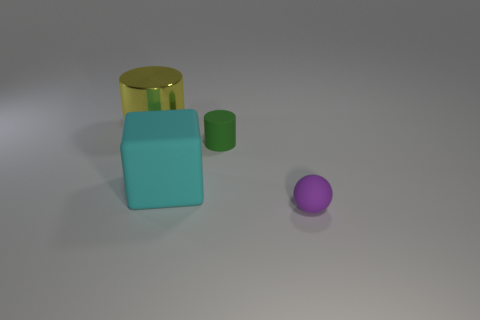What is the approximate ratio of the sizes of the yellow cylinder and the purple sphere? It looks like the diameter of the yellow cylinder is approximately twice the diameter of the purple sphere, giving us an approximate size ratio of 2:1. 